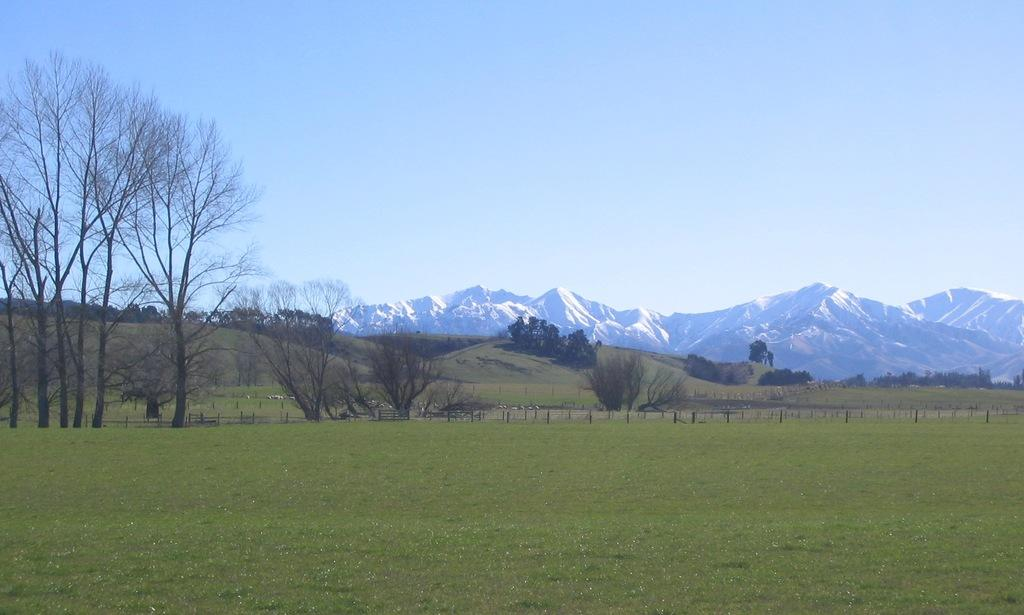What type of landscape is visible in the foreground of the image? There is a grassland in the foreground of the image. What structures can be seen in the background of the image? There are fences and trees in the background of the image. What geographical features are present in the background of the image? There are hills in the background of the image. What is the condition of the sky in the image? The sky is clear in the image. Can you see any toys scattered on the grassland in the image? There are no toys visible in the image; it features a grassland, fences, trees, hills, and a clear sky. 